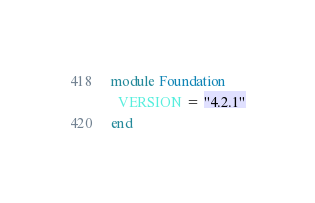Convert code to text. <code><loc_0><loc_0><loc_500><loc_500><_Ruby_>module Foundation
  VERSION = "4.2.1"
end
</code> 